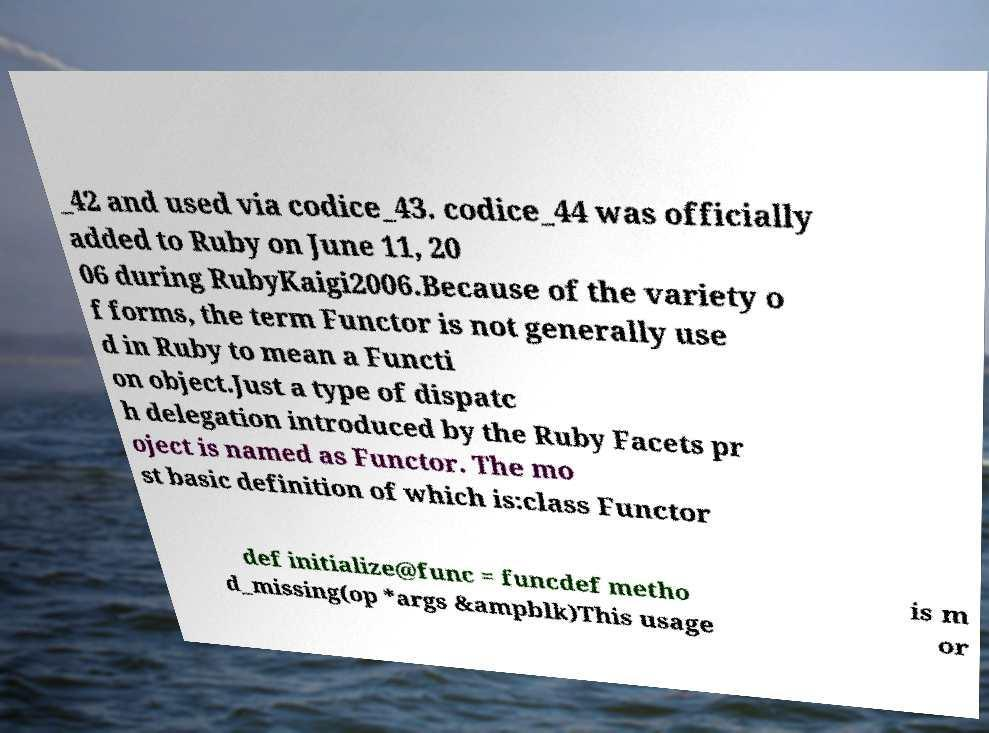Can you accurately transcribe the text from the provided image for me? _42 and used via codice_43. codice_44 was officially added to Ruby on June 11, 20 06 during RubyKaigi2006.Because of the variety o f forms, the term Functor is not generally use d in Ruby to mean a Functi on object.Just a type of dispatc h delegation introduced by the Ruby Facets pr oject is named as Functor. The mo st basic definition of which is:class Functor def initialize@func = funcdef metho d_missing(op *args &ampblk)This usage is m or 